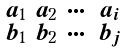<formula> <loc_0><loc_0><loc_500><loc_500>\begin{smallmatrix} a _ { 1 } & a _ { 2 } & \cdots & a _ { i } \\ b _ { 1 } & b _ { 2 } & \cdots & b _ { j } \end{smallmatrix}</formula> 